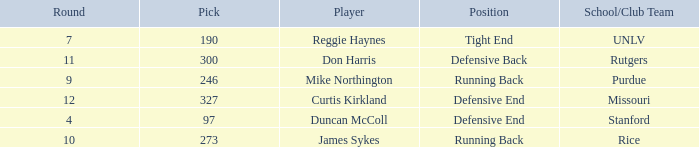What is the total number of rounds that had draft pick 97, duncan mccoll? 0.0. 